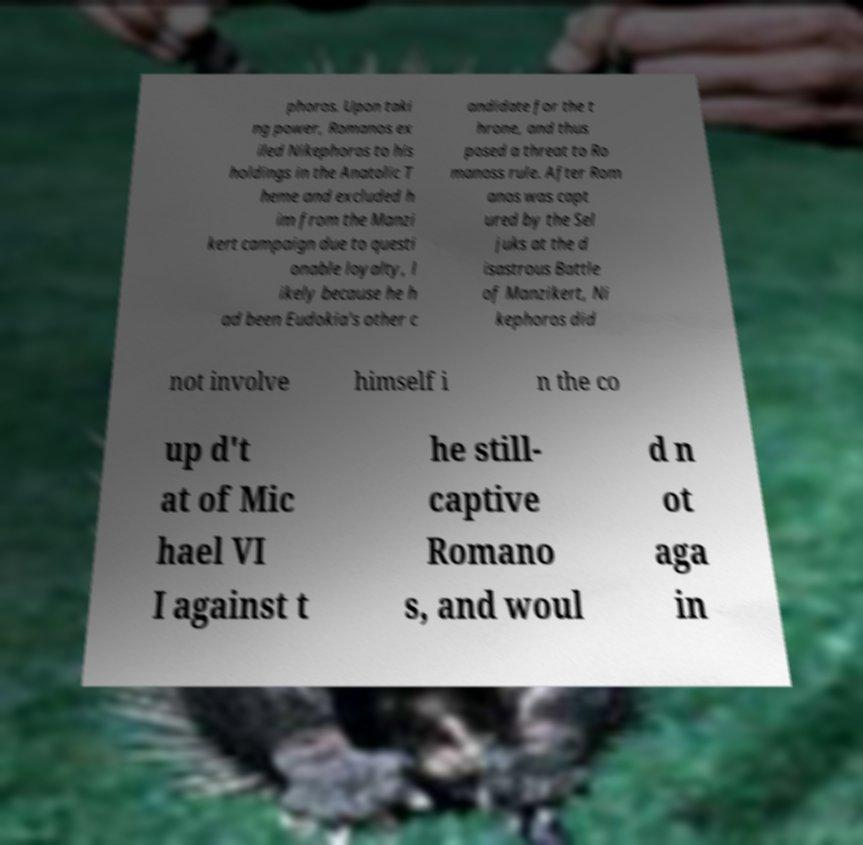What messages or text are displayed in this image? I need them in a readable, typed format. phoros. Upon taki ng power, Romanos ex iled Nikephoros to his holdings in the Anatolic T heme and excluded h im from the Manzi kert campaign due to questi onable loyalty, l ikely because he h ad been Eudokia's other c andidate for the t hrone, and thus posed a threat to Ro manoss rule. After Rom anos was capt ured by the Sel juks at the d isastrous Battle of Manzikert, Ni kephoros did not involve himself i n the co up d't at of Mic hael VI I against t he still- captive Romano s, and woul d n ot aga in 